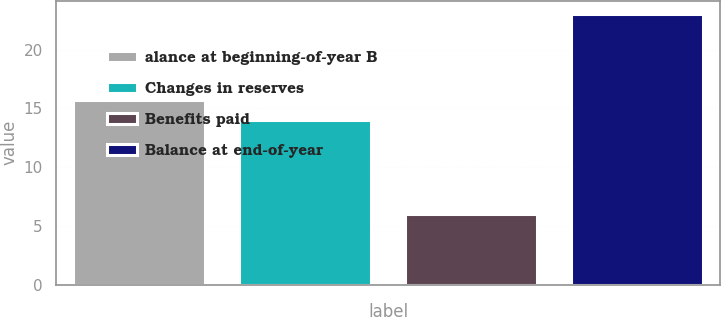<chart> <loc_0><loc_0><loc_500><loc_500><bar_chart><fcel>alance at beginning-of-year B<fcel>Changes in reserves<fcel>Benefits paid<fcel>Balance at end-of-year<nl><fcel>15.7<fcel>14<fcel>6<fcel>23<nl></chart> 